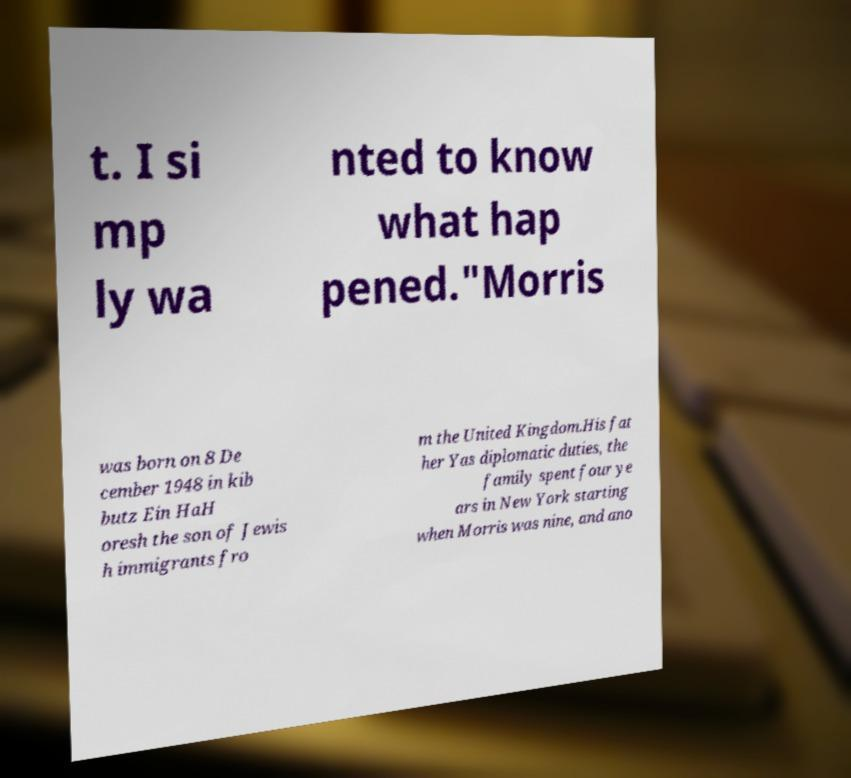What messages or text are displayed in this image? I need them in a readable, typed format. t. I si mp ly wa nted to know what hap pened."Morris was born on 8 De cember 1948 in kib butz Ein HaH oresh the son of Jewis h immigrants fro m the United Kingdom.His fat her Yas diplomatic duties, the family spent four ye ars in New York starting when Morris was nine, and ano 